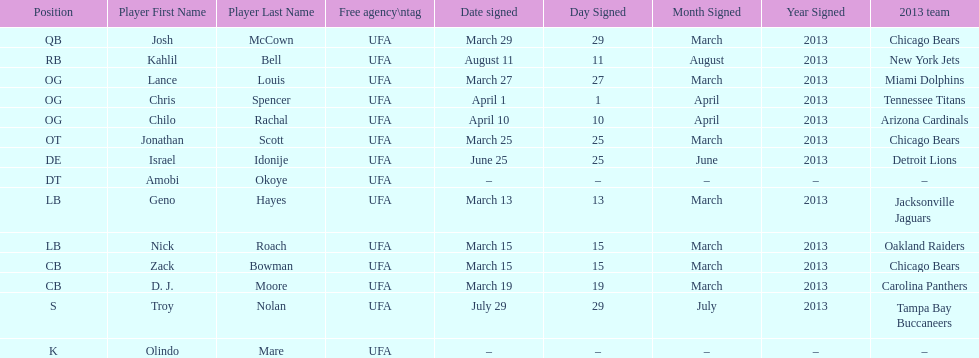Last name is also a first name beginning with "n" Troy Nolan. 